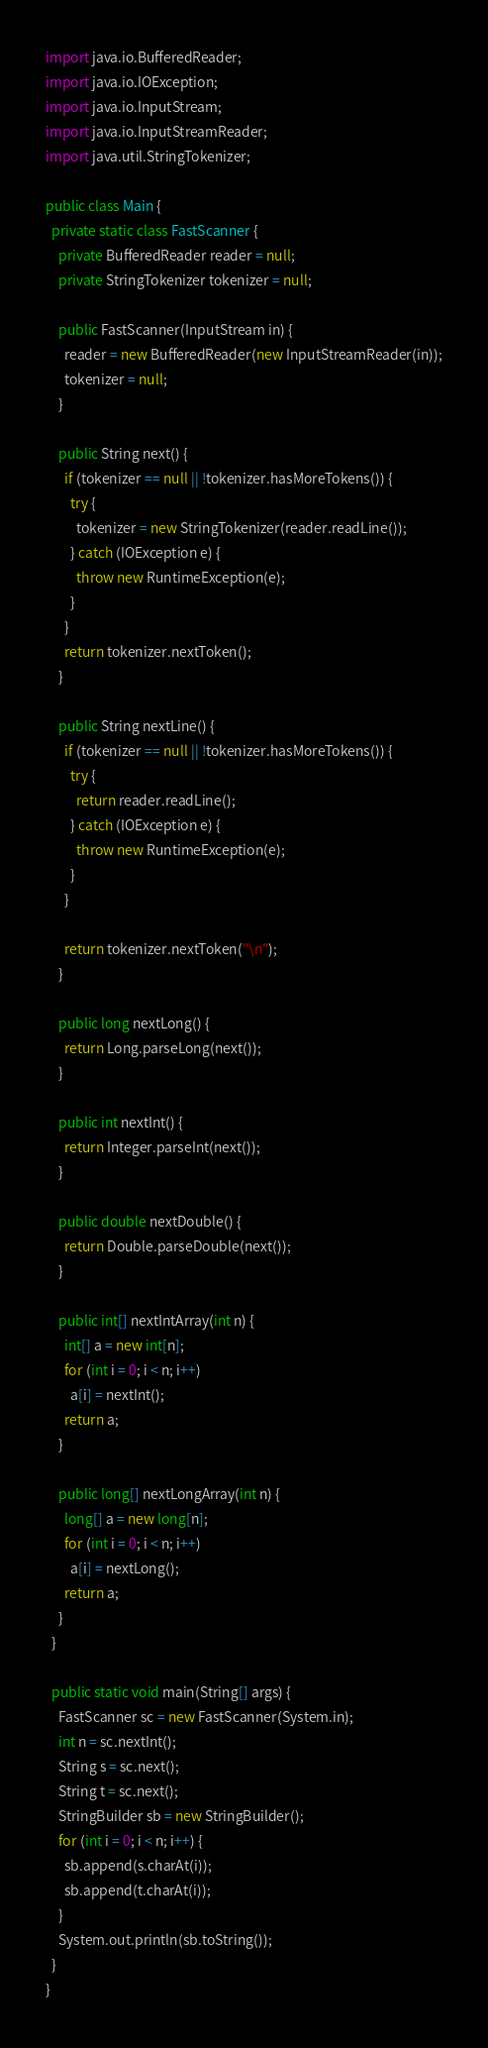Convert code to text. <code><loc_0><loc_0><loc_500><loc_500><_Java_>import java.io.BufferedReader;
import java.io.IOException;
import java.io.InputStream;
import java.io.InputStreamReader;
import java.util.StringTokenizer;

public class Main {
  private static class FastScanner {
    private BufferedReader reader = null;
    private StringTokenizer tokenizer = null;

    public FastScanner(InputStream in) {
      reader = new BufferedReader(new InputStreamReader(in));
      tokenizer = null;
    }

    public String next() {
      if (tokenizer == null || !tokenizer.hasMoreTokens()) {
        try {
          tokenizer = new StringTokenizer(reader.readLine());
        } catch (IOException e) {
          throw new RuntimeException(e);
        }
      }
      return tokenizer.nextToken();
    }

    public String nextLine() {
      if (tokenizer == null || !tokenizer.hasMoreTokens()) {
        try {
          return reader.readLine();
        } catch (IOException e) {
          throw new RuntimeException(e);
        }
      }

      return tokenizer.nextToken("\n");
    }

    public long nextLong() {
      return Long.parseLong(next());
    }

    public int nextInt() {
      return Integer.parseInt(next());
    }

    public double nextDouble() {
      return Double.parseDouble(next());
    }

    public int[] nextIntArray(int n) {
      int[] a = new int[n];
      for (int i = 0; i < n; i++)
        a[i] = nextInt();
      return a;
    }

    public long[] nextLongArray(int n) {
      long[] a = new long[n];
      for (int i = 0; i < n; i++)
        a[i] = nextLong();
      return a;
    }
  }

  public static void main(String[] args) {
    FastScanner sc = new FastScanner(System.in);
    int n = sc.nextInt();
    String s = sc.next();
    String t = sc.next();
    StringBuilder sb = new StringBuilder();
    for (int i = 0; i < n; i++) {
      sb.append(s.charAt(i));
      sb.append(t.charAt(i));
    }
    System.out.println(sb.toString());
  }
}</code> 